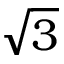Convert formula to latex. <formula><loc_0><loc_0><loc_500><loc_500>\sqrt { 3 }</formula> 